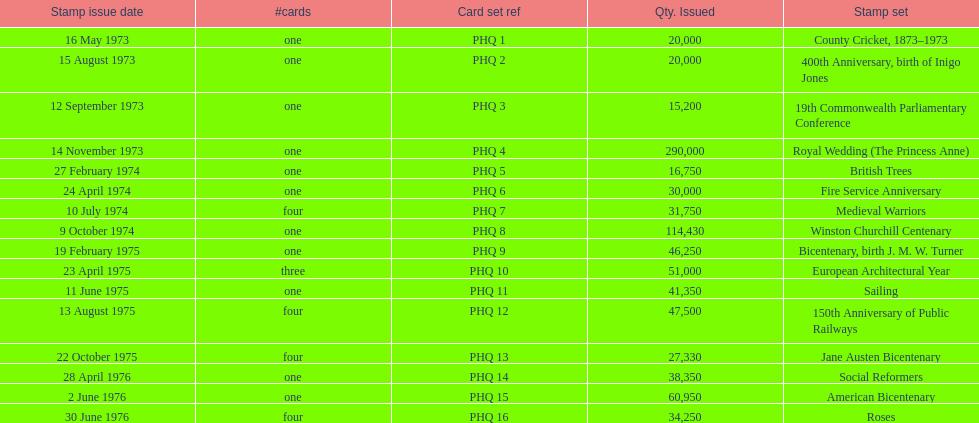How many stamp sets were released in the year 1975? 5. 